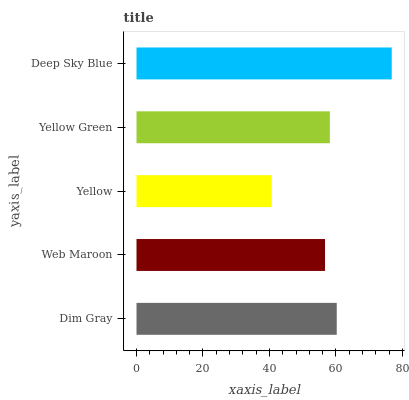Is Yellow the minimum?
Answer yes or no. Yes. Is Deep Sky Blue the maximum?
Answer yes or no. Yes. Is Web Maroon the minimum?
Answer yes or no. No. Is Web Maroon the maximum?
Answer yes or no. No. Is Dim Gray greater than Web Maroon?
Answer yes or no. Yes. Is Web Maroon less than Dim Gray?
Answer yes or no. Yes. Is Web Maroon greater than Dim Gray?
Answer yes or no. No. Is Dim Gray less than Web Maroon?
Answer yes or no. No. Is Yellow Green the high median?
Answer yes or no. Yes. Is Yellow Green the low median?
Answer yes or no. Yes. Is Dim Gray the high median?
Answer yes or no. No. Is Dim Gray the low median?
Answer yes or no. No. 